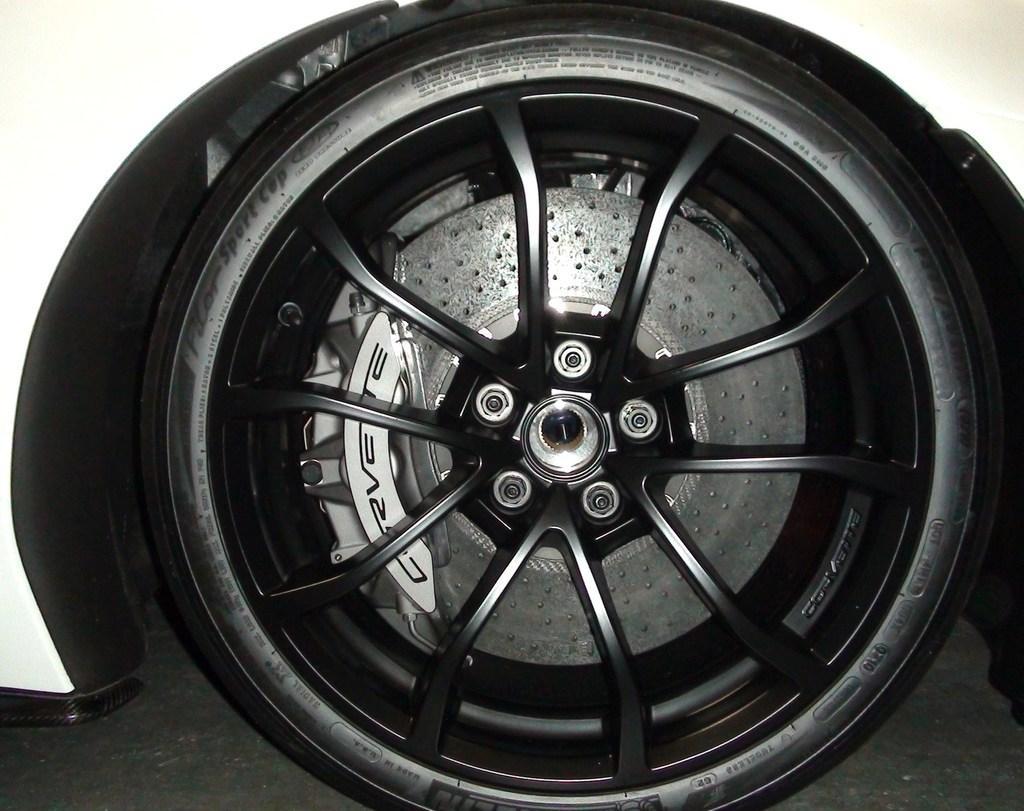In one or two sentences, can you explain what this image depicts? In this image, I can see a wheel of a vehicle. This is the tire. These are the spokes, which are connected to a center cap. I think this is a vehicle, which is white in color. 